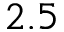<formula> <loc_0><loc_0><loc_500><loc_500>2 . 5</formula> 